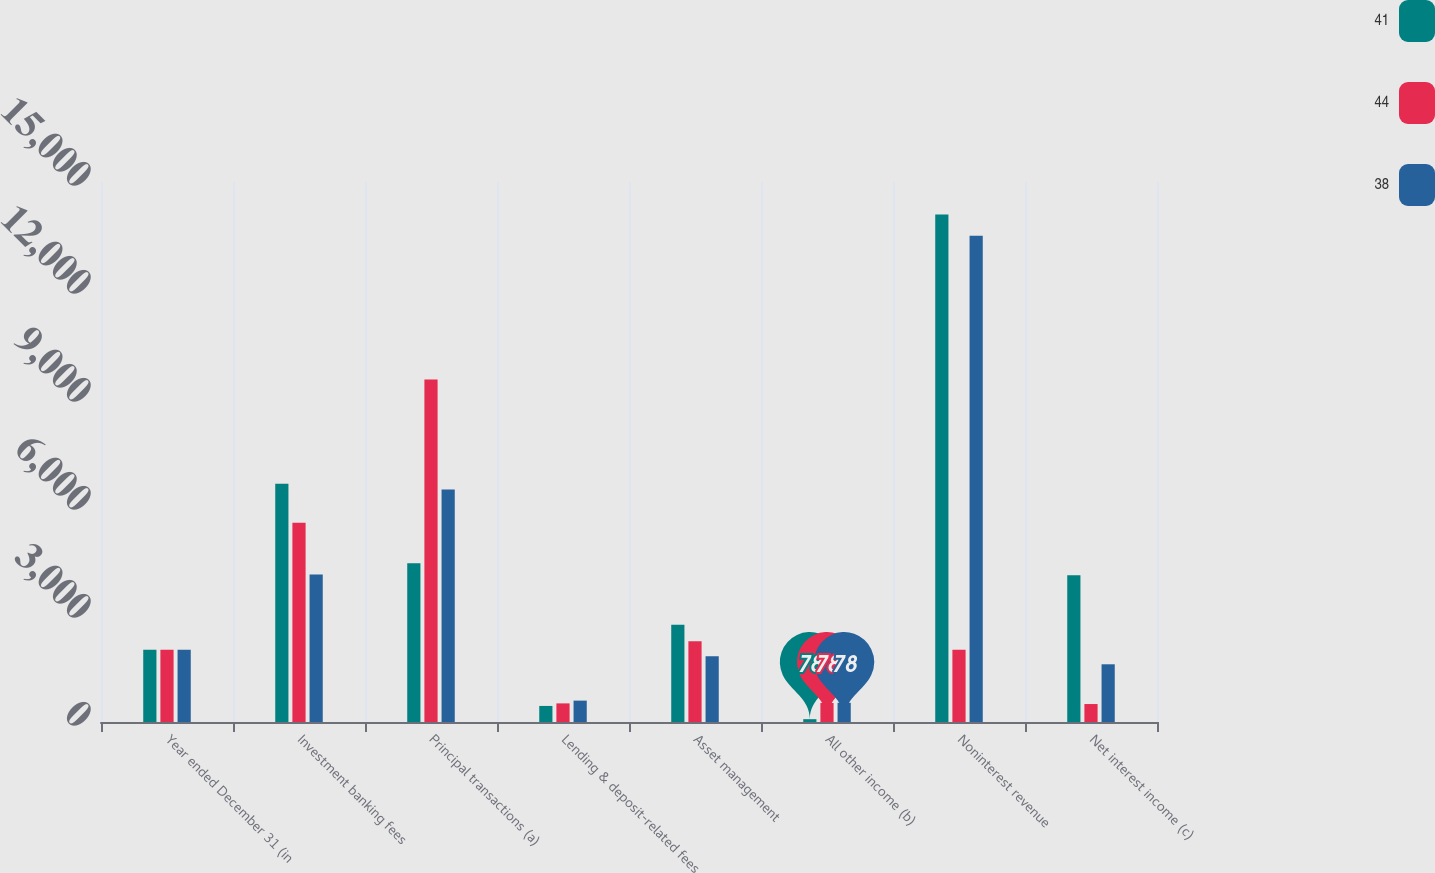<chart> <loc_0><loc_0><loc_500><loc_500><stacked_bar_chart><ecel><fcel>Year ended December 31 (in<fcel>Investment banking fees<fcel>Principal transactions (a)<fcel>Lending & deposit-related fees<fcel>Asset management<fcel>All other income (b)<fcel>Noninterest revenue<fcel>Net interest income (c)<nl><fcel>41<fcel>2007<fcel>6616<fcel>4409<fcel>446<fcel>2701<fcel>78<fcel>14094<fcel>4076<nl><fcel>44<fcel>2006<fcel>5537<fcel>9512<fcel>517<fcel>2240<fcel>528<fcel>2007<fcel>499<nl><fcel>38<fcel>2005<fcel>4096<fcel>6459<fcel>594<fcel>1824<fcel>534<fcel>13507<fcel>1603<nl></chart> 